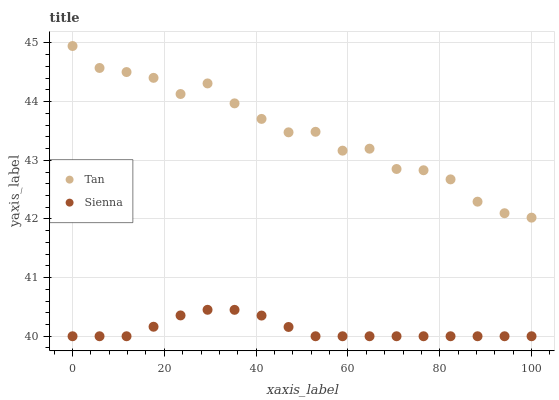Does Sienna have the minimum area under the curve?
Answer yes or no. Yes. Does Tan have the maximum area under the curve?
Answer yes or no. Yes. Does Tan have the minimum area under the curve?
Answer yes or no. No. Is Sienna the smoothest?
Answer yes or no. Yes. Is Tan the roughest?
Answer yes or no. Yes. Is Tan the smoothest?
Answer yes or no. No. Does Sienna have the lowest value?
Answer yes or no. Yes. Does Tan have the lowest value?
Answer yes or no. No. Does Tan have the highest value?
Answer yes or no. Yes. Is Sienna less than Tan?
Answer yes or no. Yes. Is Tan greater than Sienna?
Answer yes or no. Yes. Does Sienna intersect Tan?
Answer yes or no. No. 